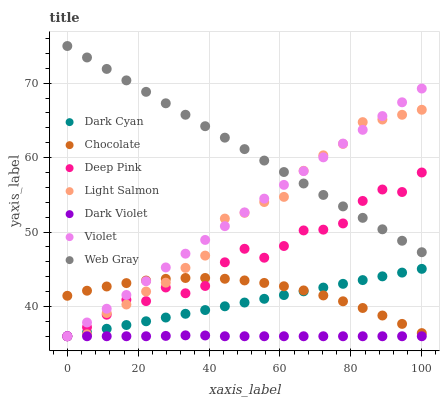Does Dark Violet have the minimum area under the curve?
Answer yes or no. Yes. Does Web Gray have the maximum area under the curve?
Answer yes or no. Yes. Does Deep Pink have the minimum area under the curve?
Answer yes or no. No. Does Deep Pink have the maximum area under the curve?
Answer yes or no. No. Is Violet the smoothest?
Answer yes or no. Yes. Is Deep Pink the roughest?
Answer yes or no. Yes. Is Dark Violet the smoothest?
Answer yes or no. No. Is Dark Violet the roughest?
Answer yes or no. No. Does Light Salmon have the lowest value?
Answer yes or no. Yes. Does Chocolate have the lowest value?
Answer yes or no. No. Does Web Gray have the highest value?
Answer yes or no. Yes. Does Deep Pink have the highest value?
Answer yes or no. No. Is Dark Violet less than Web Gray?
Answer yes or no. Yes. Is Web Gray greater than Dark Cyan?
Answer yes or no. Yes. Does Dark Violet intersect Dark Cyan?
Answer yes or no. Yes. Is Dark Violet less than Dark Cyan?
Answer yes or no. No. Is Dark Violet greater than Dark Cyan?
Answer yes or no. No. Does Dark Violet intersect Web Gray?
Answer yes or no. No. 